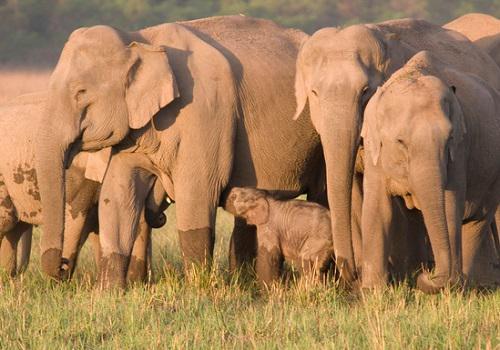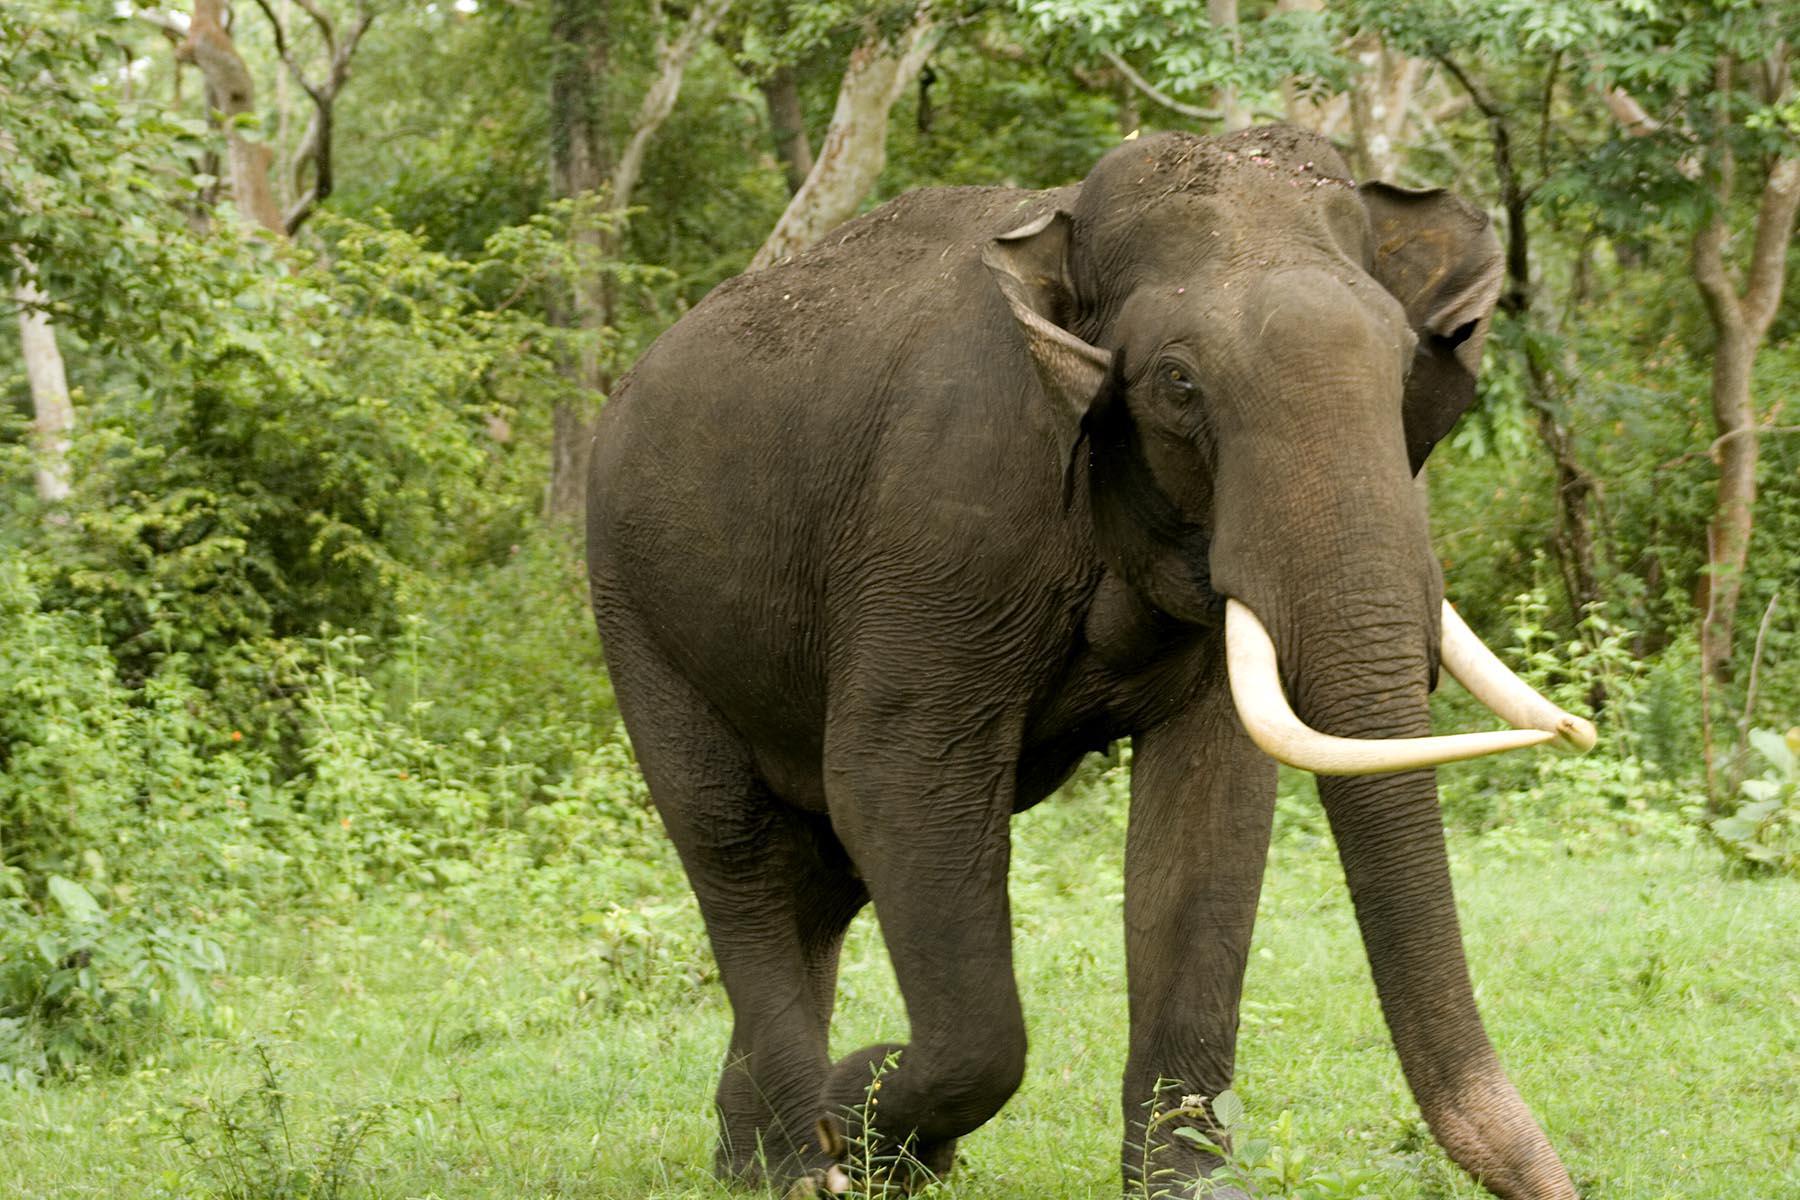The first image is the image on the left, the second image is the image on the right. For the images displayed, is the sentence "The photo on the right contains a single elephant." factually correct? Answer yes or no. Yes. The first image is the image on the left, the second image is the image on the right. Examine the images to the left and right. Is the description "Multiple pairs of elephant tusks are visible." accurate? Answer yes or no. No. 